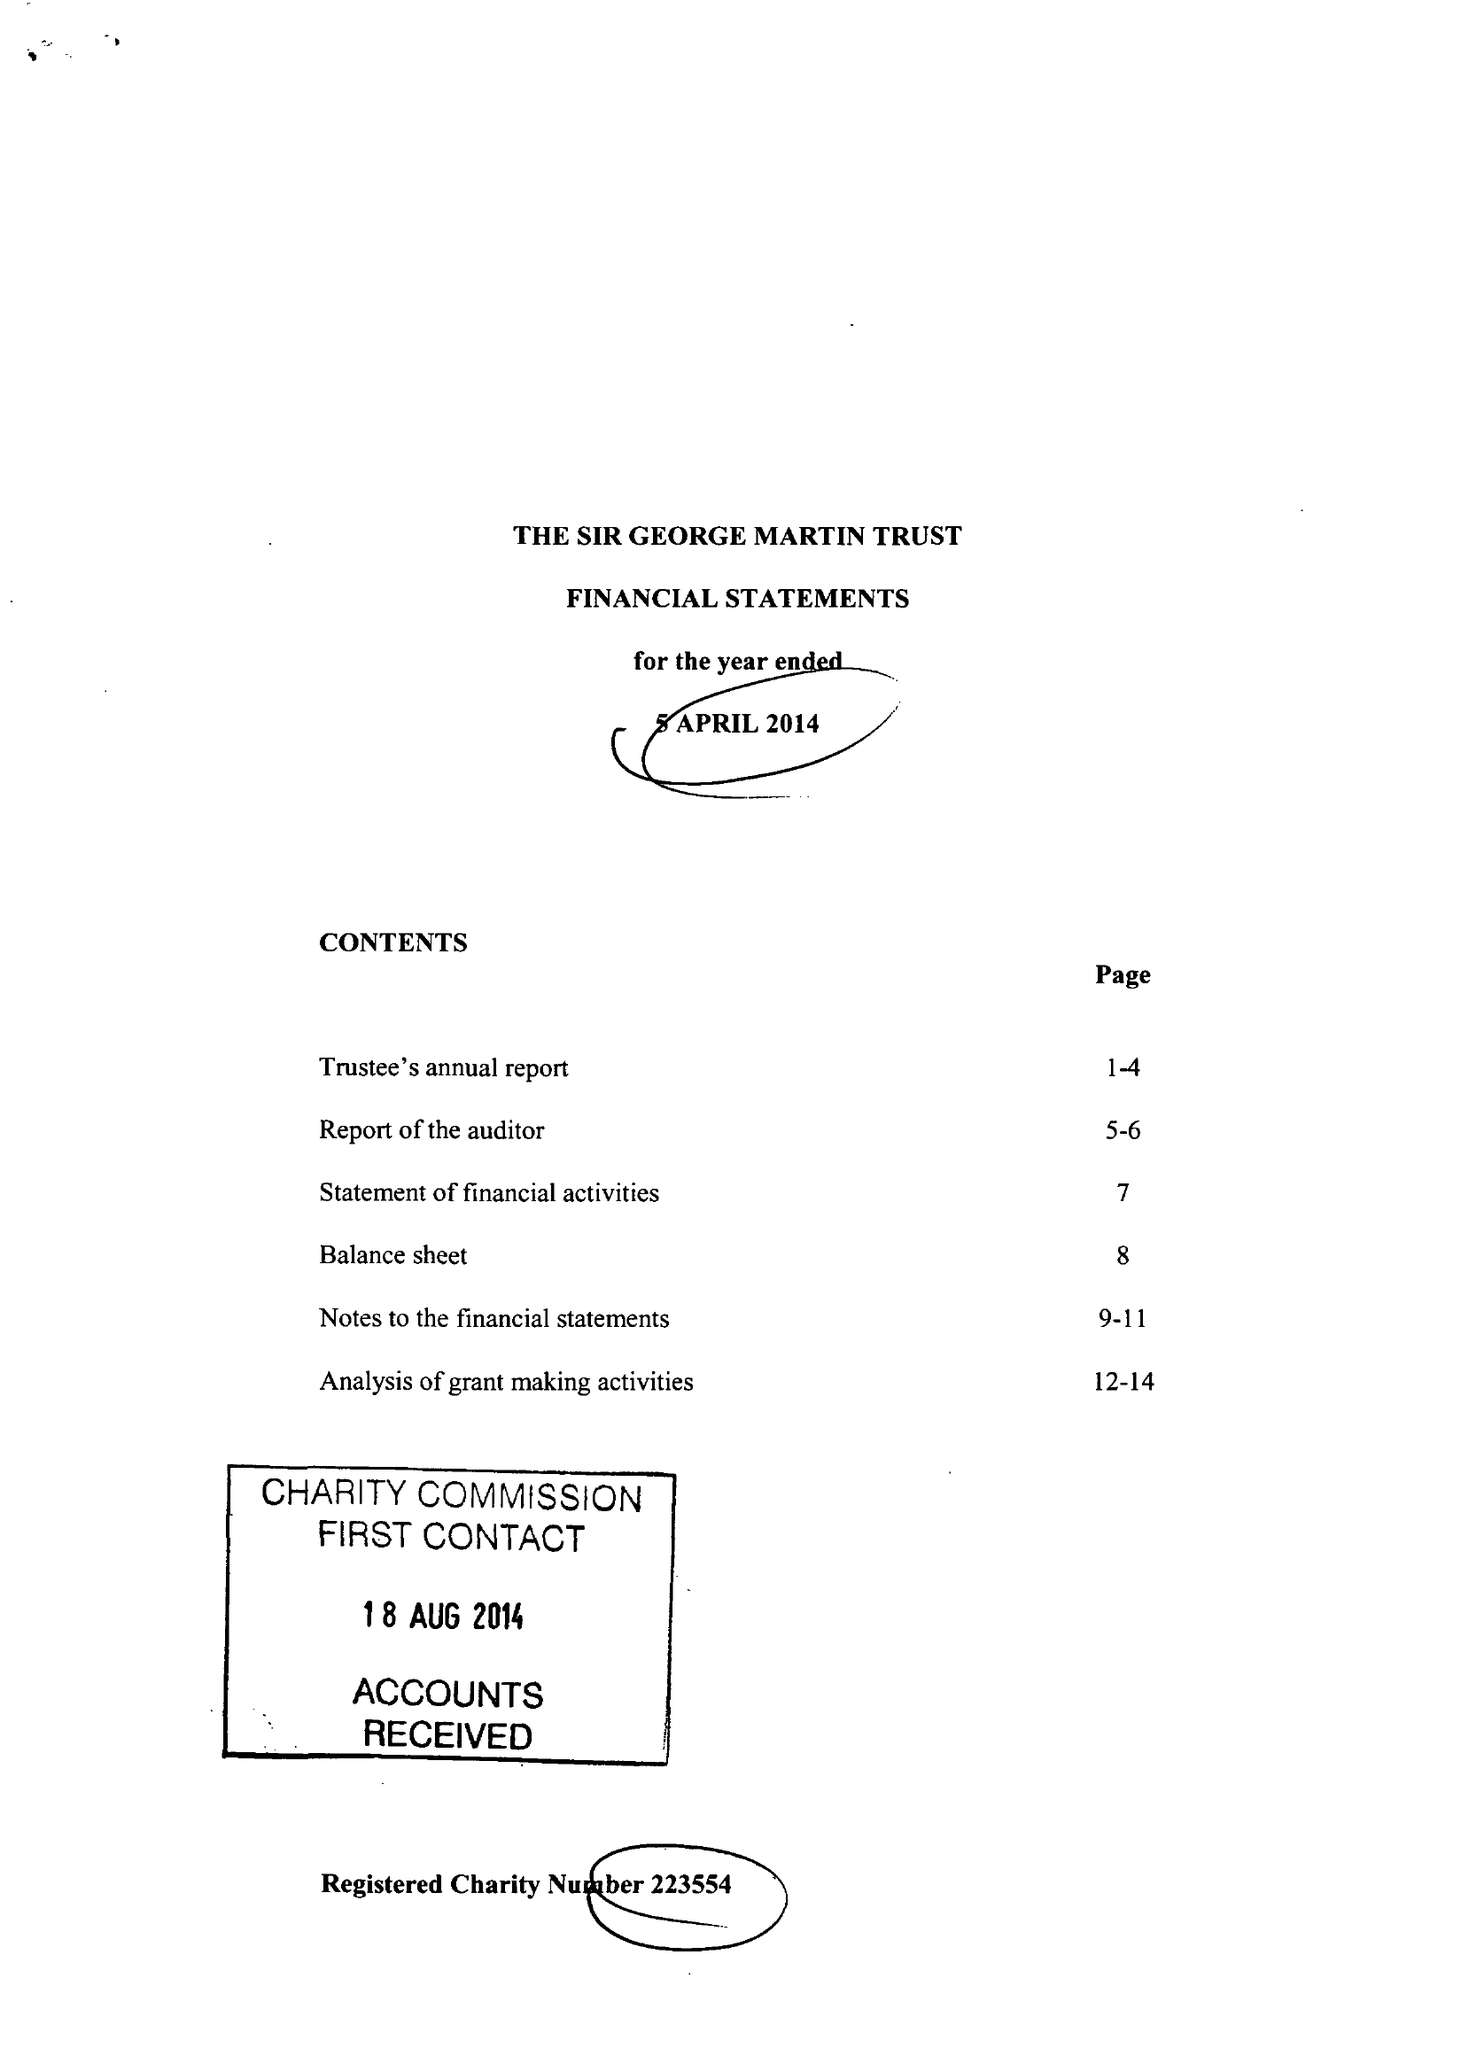What is the value for the charity_name?
Answer the question using a single word or phrase. Sir George Martin Trust 